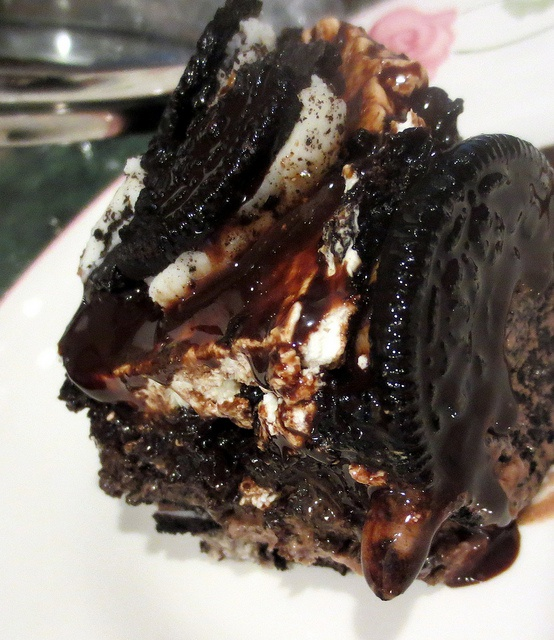Describe the objects in this image and their specific colors. I can see a cake in black, maroon, and gray tones in this image. 